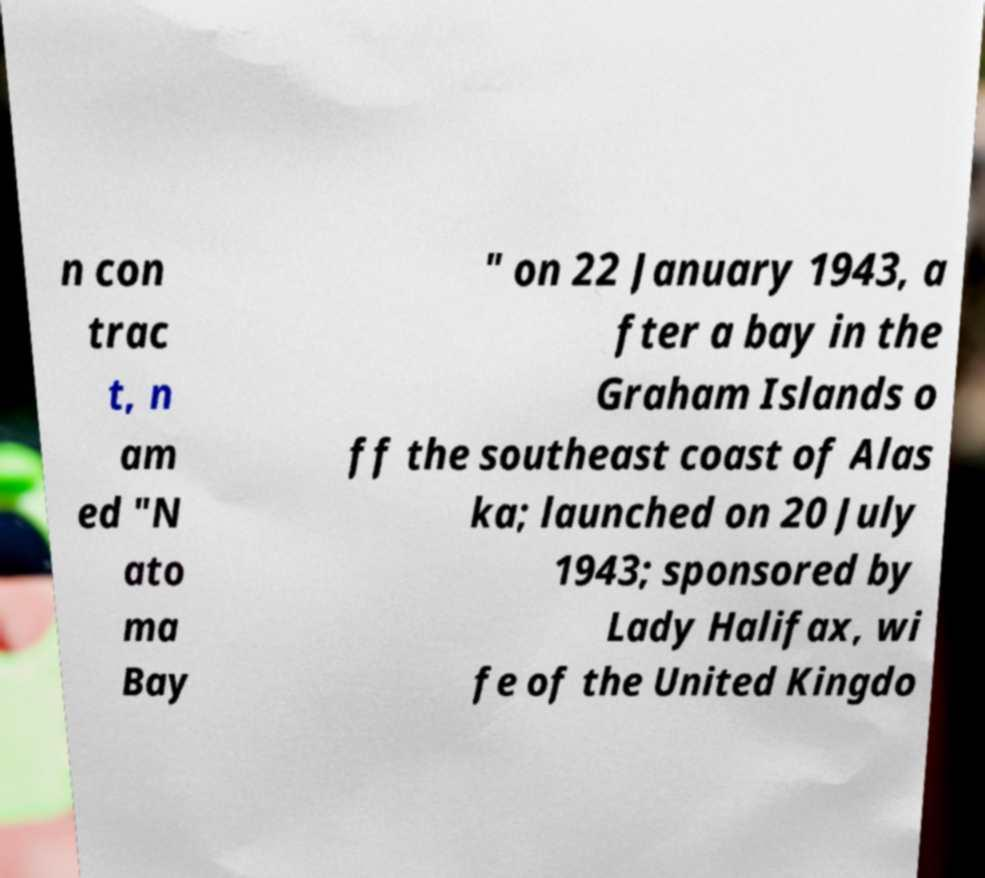Can you accurately transcribe the text from the provided image for me? n con trac t, n am ed "N ato ma Bay " on 22 January 1943, a fter a bay in the Graham Islands o ff the southeast coast of Alas ka; launched on 20 July 1943; sponsored by Lady Halifax, wi fe of the United Kingdo 